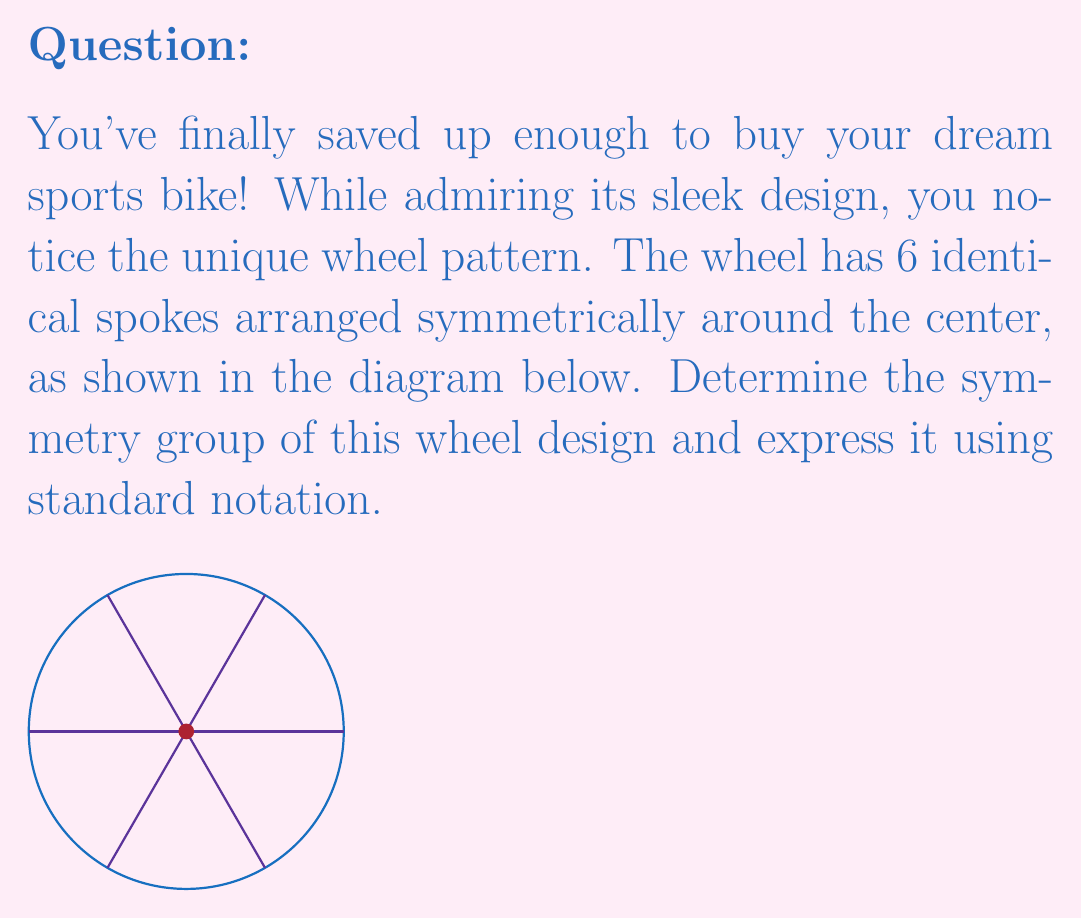Could you help me with this problem? Let's approach this step-by-step:

1) First, we need to identify all the symmetries of the wheel:

   a) Rotational symmetries: The wheel can be rotated by multiples of 60° (or π/3 radians) and still look the same. There are 6 such rotations (including the identity rotation).
   
   b) Reflection symmetries: There are 6 lines of reflection - one through each spoke and one between each pair of adjacent spokes.

2) The total number of symmetries is thus 12 (6 rotations + 6 reflections).

3) This group of symmetries is isomorphic to the dihedral group of order 12, denoted as $D_6$ or $D_{12}$ (depending on the notation system used).

4) The group can be generated by two elements:
   - $r$: a rotation by 60°
   - $s$: a reflection across any line of symmetry

5) These generators satisfy the relations:
   $r^6 = e$ (identity)
   $s^2 = e$
   $srs = r^{-1}$

6) The elements of the group can be written as:
   $\{e, r, r^2, r^3, r^4, r^5, s, sr, sr^2, sr^3, sr^4, sr^5\}$

7) This group is non-abelian, as rotation and reflection do not generally commute.
Answer: $D_6$ (or $D_{12}$) 